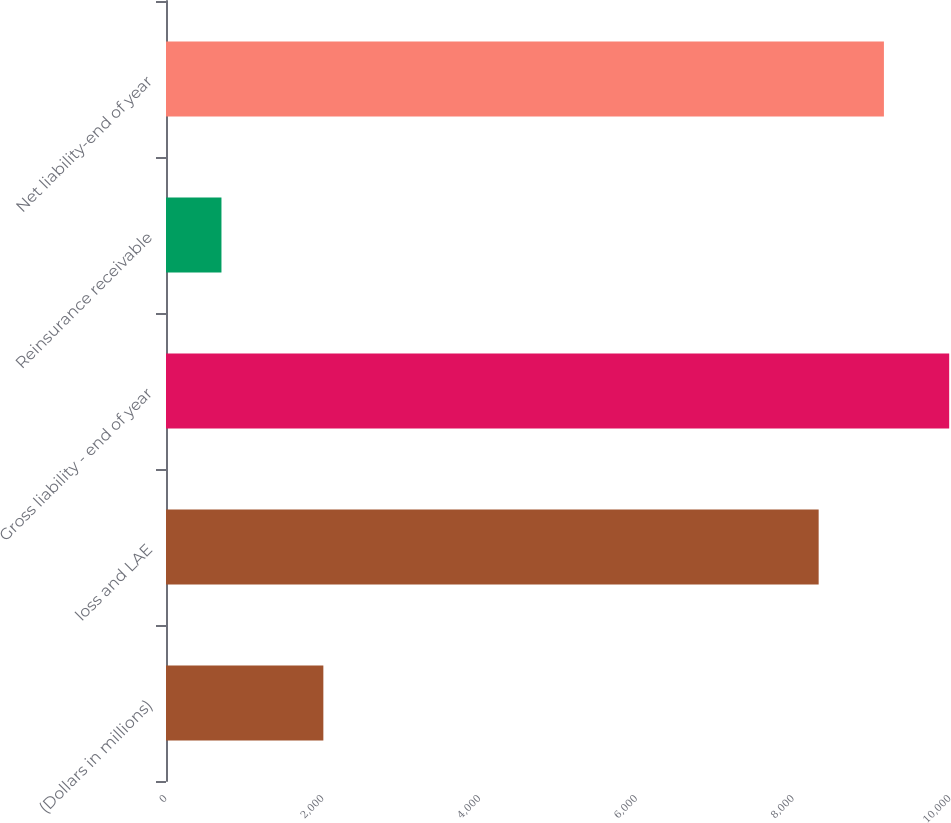<chart> <loc_0><loc_0><loc_500><loc_500><bar_chart><fcel>(Dollars in millions)<fcel>loss and LAE<fcel>Gross liability - end of year<fcel>Reinsurance receivable<fcel>Net liability-end of year<nl><fcel>2007<fcel>8324.7<fcel>9989.66<fcel>707.4<fcel>9157.18<nl></chart> 